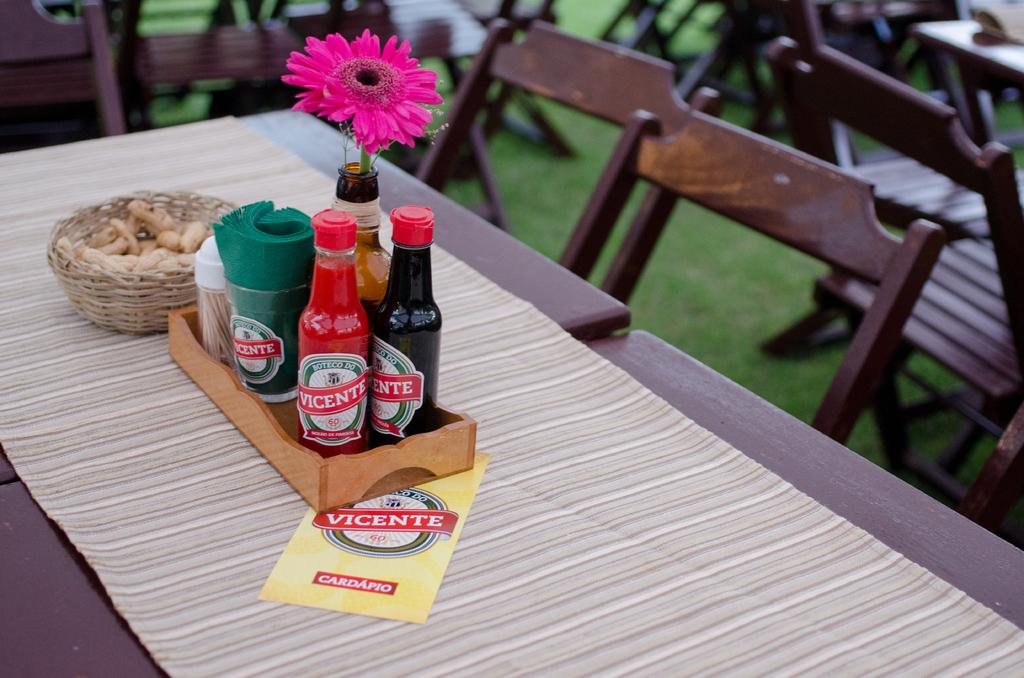<image>
Describe the image concisely. A table with condiments in the middle by the brand vicente. 